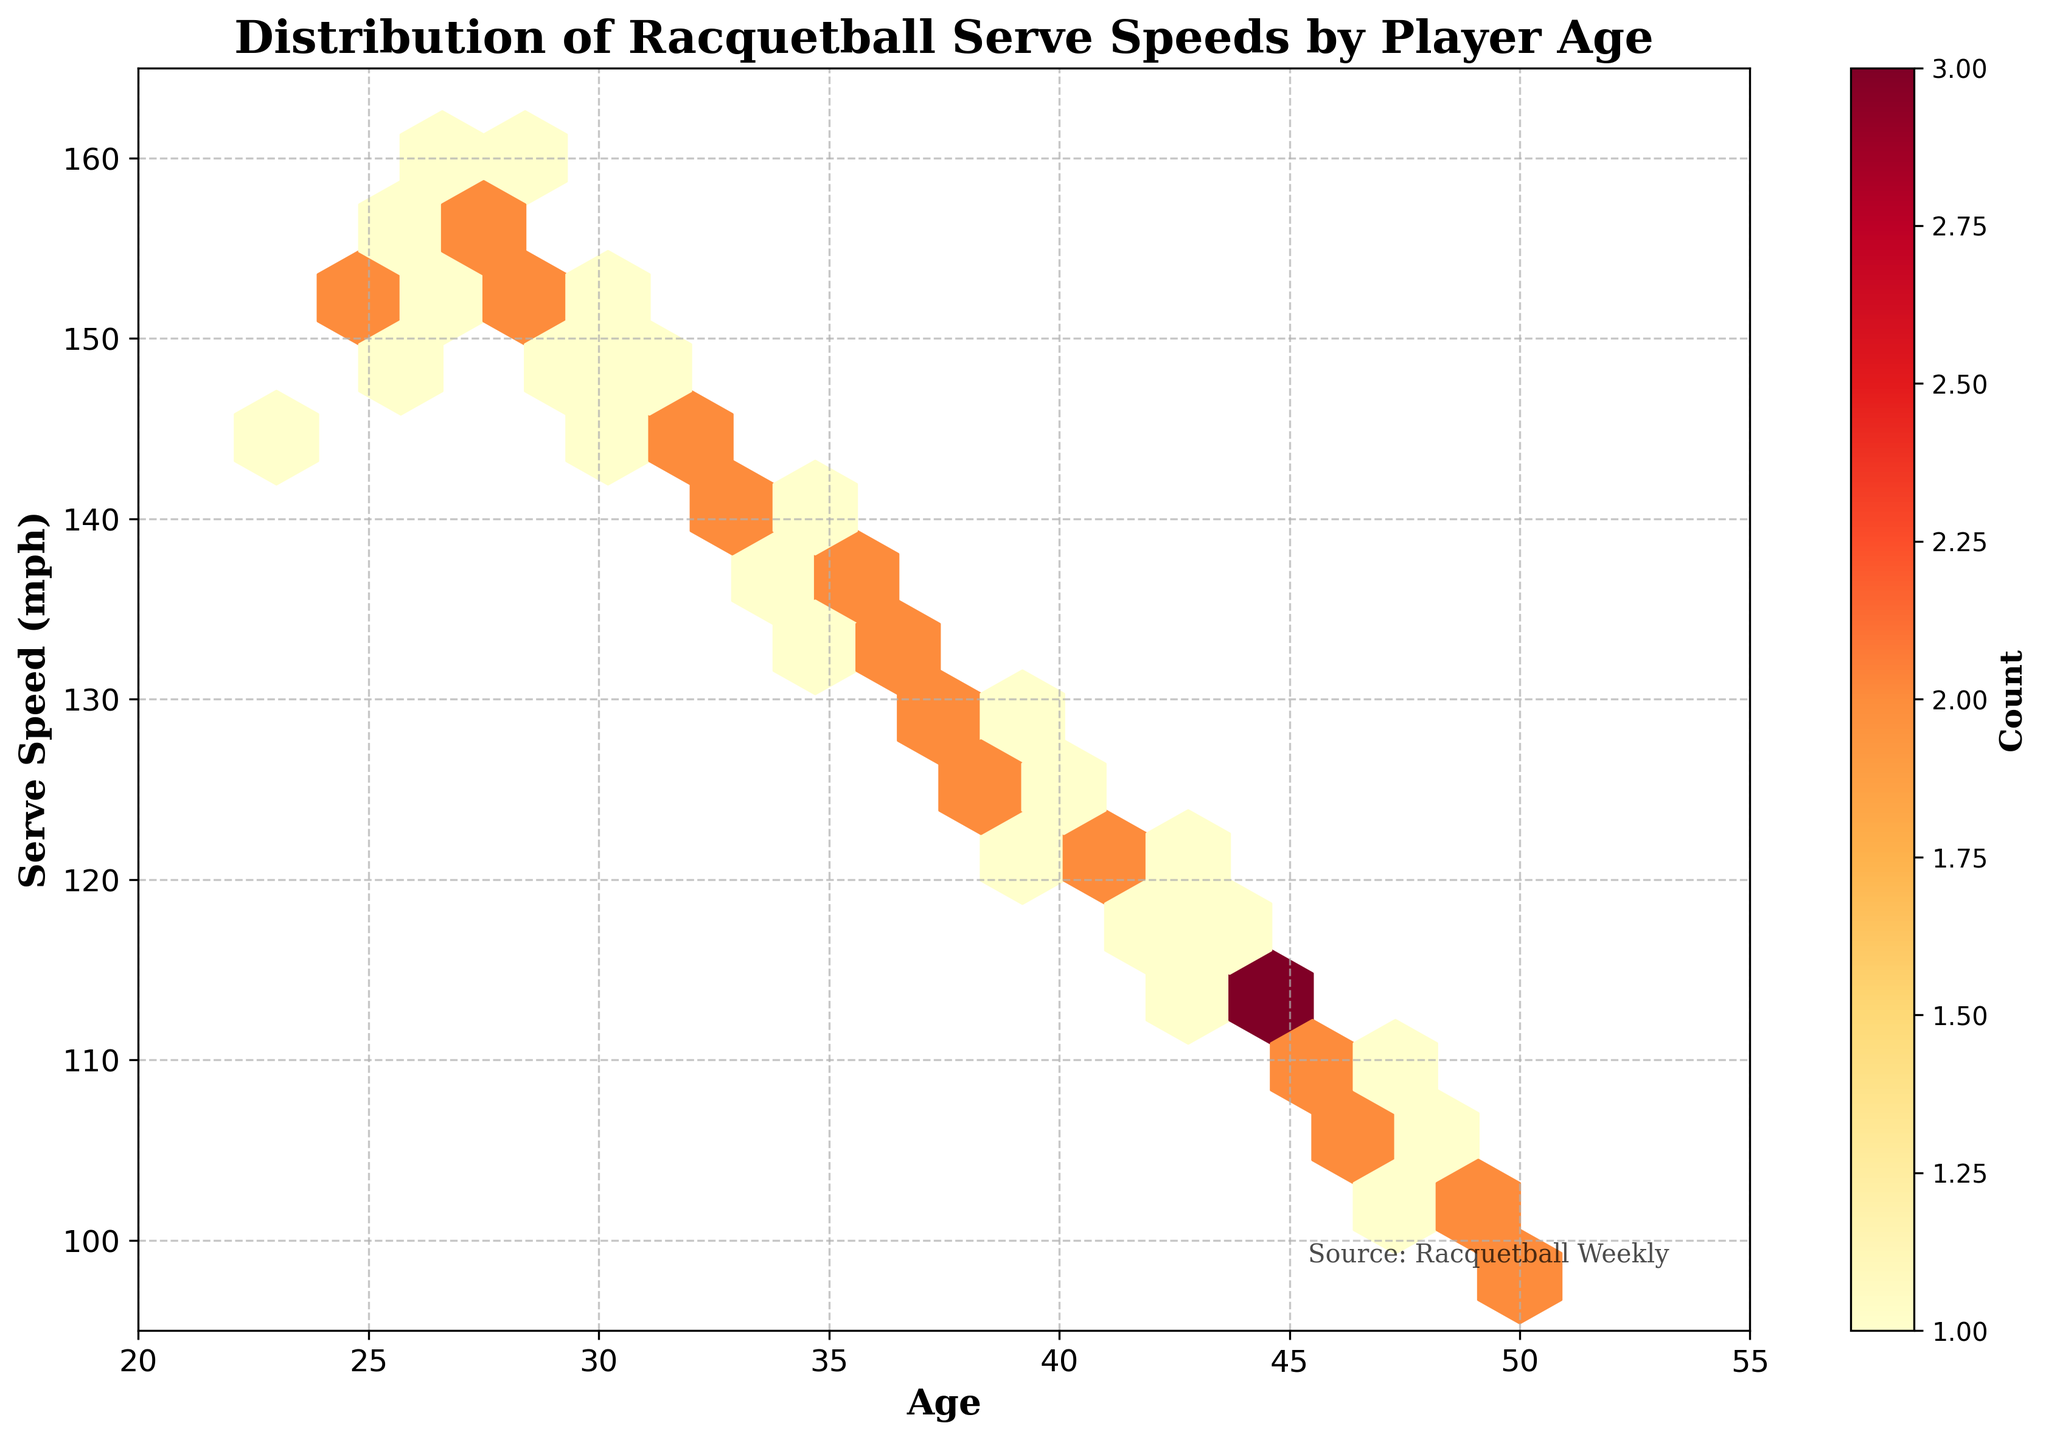What is the title of the figure? The title is usually placed at the top of the figure. Here, it states 'Distribution of Racquetball Serve Speeds by Player Age'.
Answer: Distribution of Racquetball Serve Speeds by Player Age What range of ages is represented on the x-axis? The x-axis range is indicated by the labeling next to the x-axis, from 20 to 55, which represents the age of players.
Answer: 20 to 55 Which age group has the highest concentration of serve speeds between 145 and 155 mph? By looking at the color density in the figure, where there is a high concentration of hexagons, the age group around 25 to 30 seems to have the highest concentration of serves in this speed range.
Answer: 25 to 30 How does serve speed generally trend with age? You can observe the trend by following the hexagons from left (younger ages) to right (older ages). Serve speeds tend to decrease as age increases.
Answer: Decreases What is the serve speed range of the youngest players in the dataset? By focusing on the hexagons corresponding to the youngest players (around 23 years old), the serve speeds range approximately between 140 and 155 mph.
Answer: 140 to 155 mph What is the lowest serve speed observed in the dataset, based on the figure? The figure shows the y-axis range and the distribution of hexagons. The lowest speeds are close to the 100 mph mark.
Answer: Around 100 mph Which age group shows the lowest recorded serve speeds and what is the approximate serve speed? By looking at the rightmost portion of the plot (around 50 years), the lowest serves seem to hover around 100 mph.
Answer: 50 years, 100 mph Is there a visible clustering of data points in the figure? Yes, clusters are visible where the hexagons are tightly packed and colored more intensely, indicating higher serve speeds and ages.
Answer: Yes How does the distribution of serve speeds change for players over 40 years old? Serve speeds for players over 40 years old are generally lower, with speeds ranging from about 100 to 125 mph, and these hexagons are less densely packed.
Answer: Lower serve speeds, 100 to 125 mph Where are the hexagons with the highest counts located? The hexagons with the highest counts, indicated by the most intense color (dark red), are located around ages 25-30 with serve speeds between 145 and 155 mph.
Answer: Around ages 25-30, 145-155 mph 